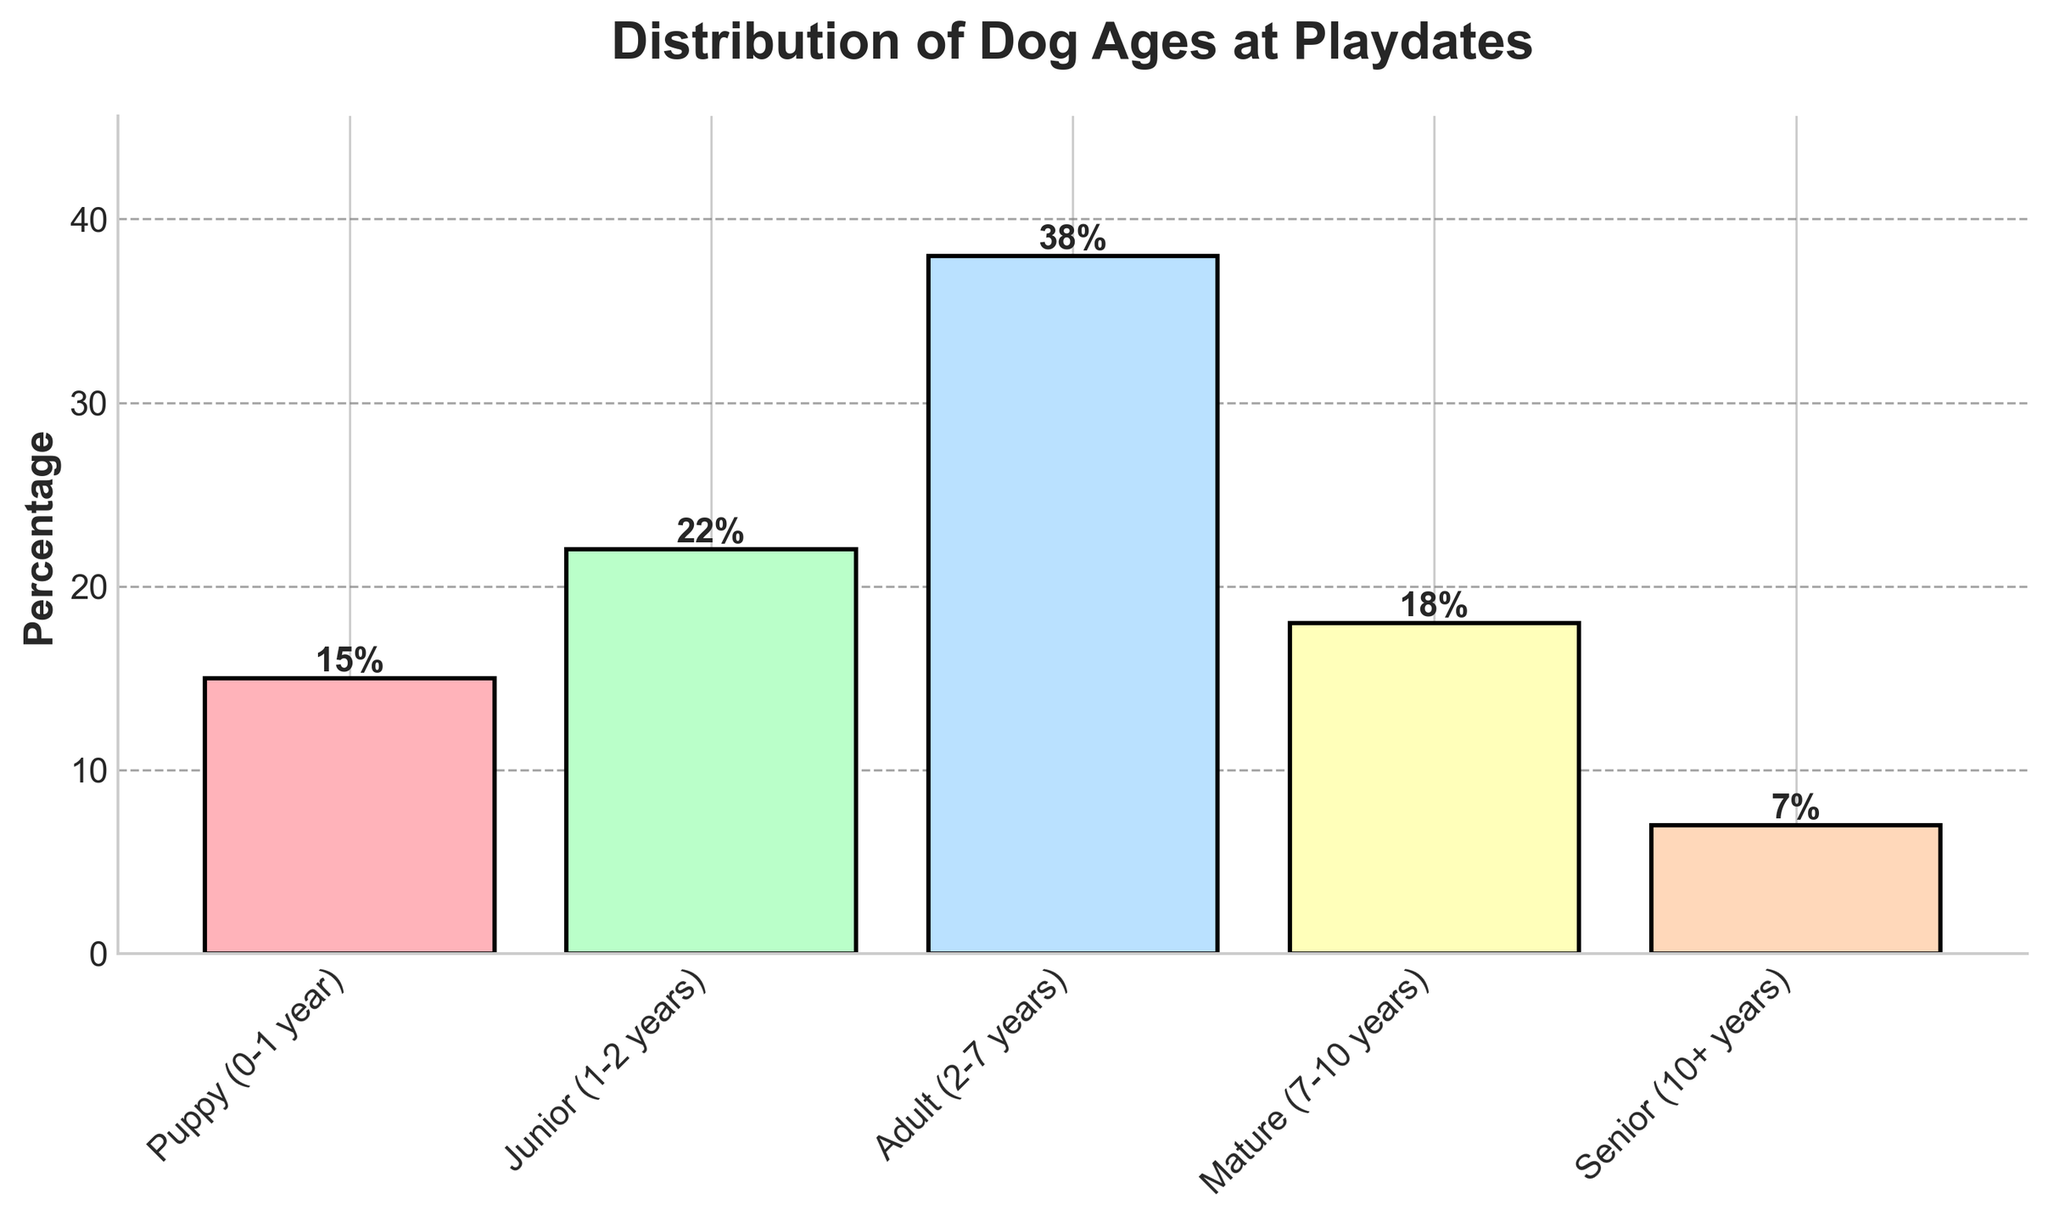What percentage of dogs at the playdates are considered 'Adult'? According to the bar chart, the 'Adult' life stage is represented by a specific bar. The height of this bar corresponds to the percentage of dogs in the adult category, which is labeled at the top of the bar as 38%.
Answer: 38% Which life stage has the smallest representation at playdates? By observing the heights of the bars, the one with the shortest height indicates the smallest representation. The 'Senior (10+ years)' bar is the shortest, marked with a 7% label.
Answer: Senior (10+ years) How does the representation of 'Puppy' compare to 'Junior'? The 'Puppy (0-1 year)' category has a bar labeled with 15%, while the 'Junior (1-2 years)' category has a bar labeled with 22%. By comparing these two percentages, 22% (Junior) is greater than 15% (Puppy).
Answer: Junior higher than Puppy What is the combined percentage of 'Mature' and 'Senior' dogs at the playdates? Adding the percentages from the 'Mature (7-10 years)' bar, which is 18%, and the 'Senior (10+ years)' bar, which is 7%, gives us the combined percentage: 18% + 7% = 25%.
Answer: 25% Is there a higher percentage of 'Adult' or 'Mature' dogs at the playdates? The 'Adult (2-7 years)' bar is labeled with 38%, while the 'Mature (7-10 years)' bar is labeled with 18%. Comparing these values, 38% (Adult) is greater than 18% (Mature).
Answer: Adult higher than Mature What life stage has the second highest percentage of dogs at playdates? The highest percentage is 'Adult' with 38%. The next highest percentage is 'Junior (1-2 years)' with 22%.
Answer: Junior (1-2 years) How does the combined percentage of 'Puppy' and 'Junior' compare to that of 'Mature' and 'Senior'? First, calculate the combined percentages: 'Puppy (0-1 year)' is 15% and 'Junior (1-2 years)' is 22%, so 15% + 22% = 37%. 'Mature (7-10 years)' is 18% and 'Senior (10+ years)' is 7%, so 18% + 7% = 25%. Comparing 37% and 25%, 37% (Puppy + Junior) is greater.
Answer: Puppy + Junior greater than Mature + Senior Which life stage is represented by the blue bar? Observing the color-coding of the bars, the blue bar represents the 'Adult (2-7 years)' life stage.
Answer: Adult (2-7 years) What is the difference in percentage between the 'Puppy' and 'Senior' life stages? The 'Puppy (0-1 year)' bar shows 15%, and the 'Senior (10+ years)' bar shows 7%. Subtracting these percentages: 15% - 7% = 8%.
Answer: 8% 